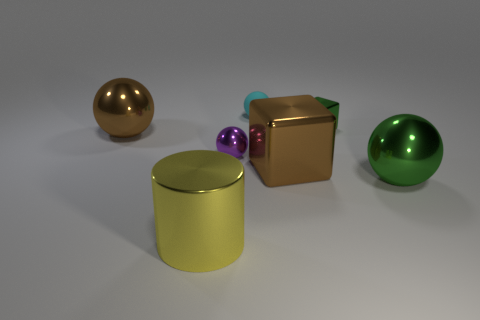Subtract all purple metal balls. How many balls are left? 3 Subtract all cyan spheres. How many spheres are left? 3 Add 1 large cubes. How many objects exist? 8 Subtract all cylinders. How many objects are left? 6 Subtract all gray balls. Subtract all green cylinders. How many balls are left? 4 Subtract 0 yellow blocks. How many objects are left? 7 Subtract all cyan rubber things. Subtract all cyan things. How many objects are left? 5 Add 5 large brown shiny things. How many large brown shiny things are left? 7 Add 2 tiny cyan matte spheres. How many tiny cyan matte spheres exist? 3 